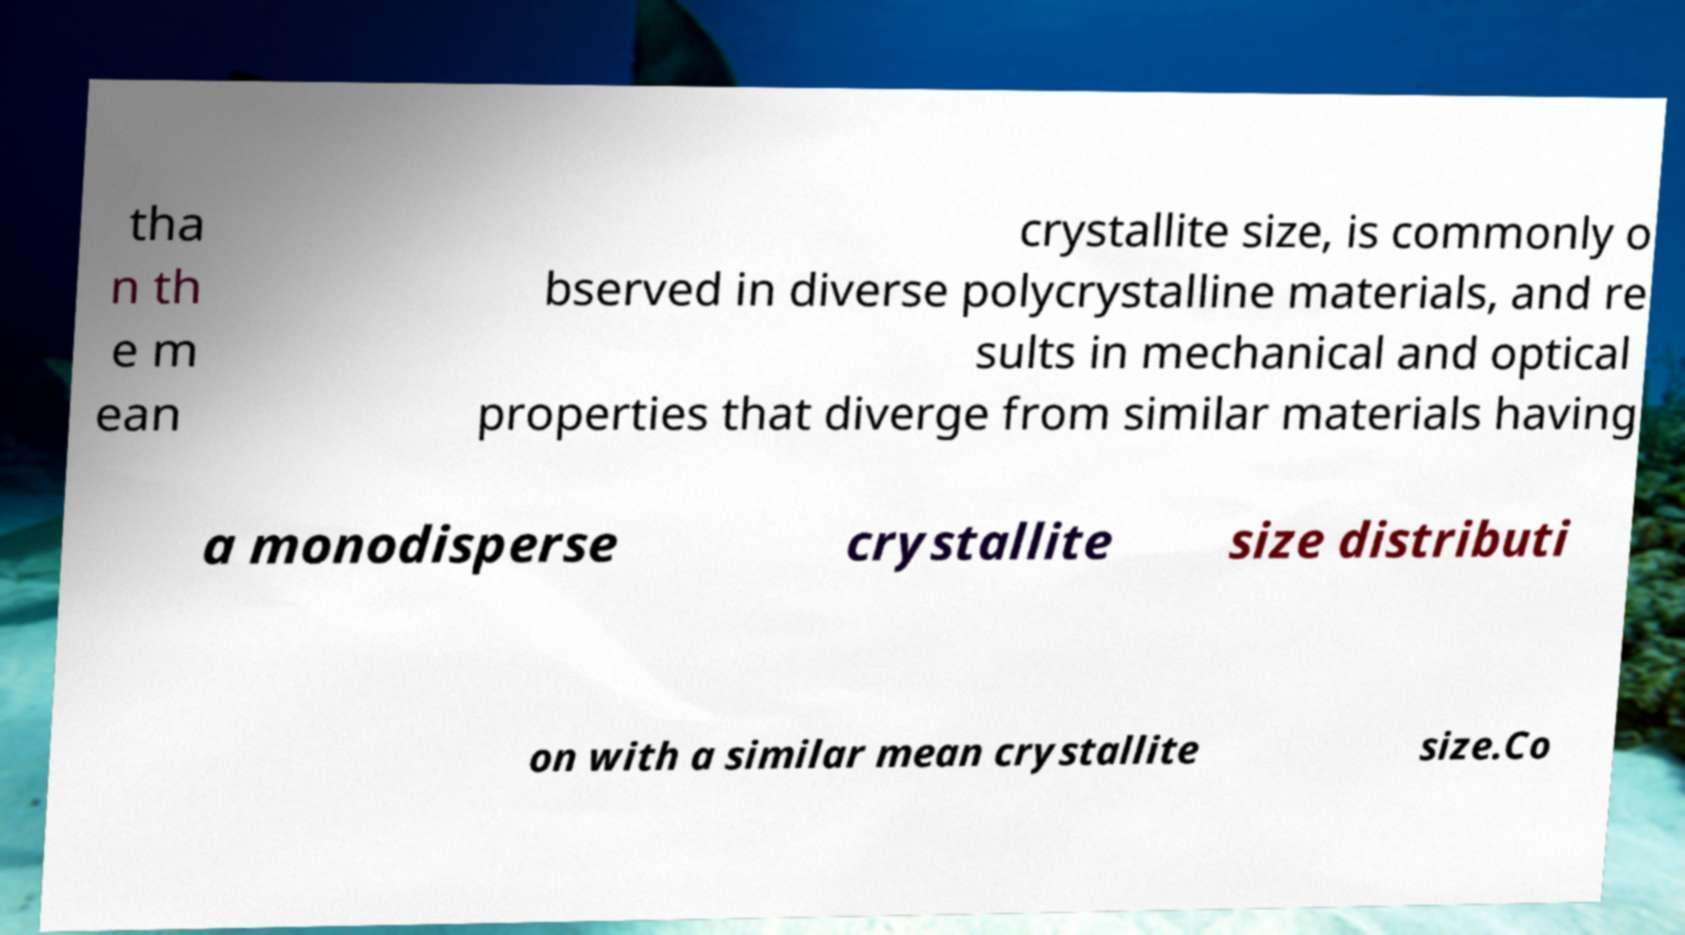I need the written content from this picture converted into text. Can you do that? tha n th e m ean crystallite size, is commonly o bserved in diverse polycrystalline materials, and re sults in mechanical and optical properties that diverge from similar materials having a monodisperse crystallite size distributi on with a similar mean crystallite size.Co 